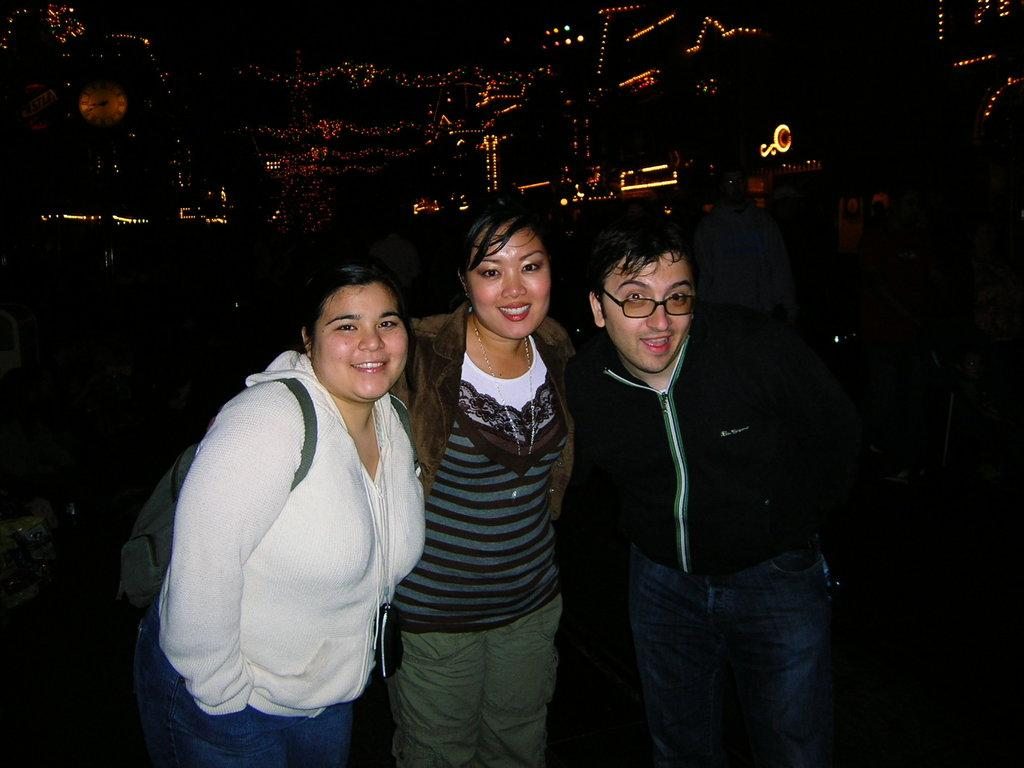How many people are in the image? There are three people in the image. What are the people in the image doing? The people are posing for a picture. Can you describe any accessories or items worn by the people? One person is wearing a bag, and another person is wearing glasses. What type of dinosaurs can be seen running in the background of the image? There are no dinosaurs or running depicted in the image; it features three people posing for a picture. 